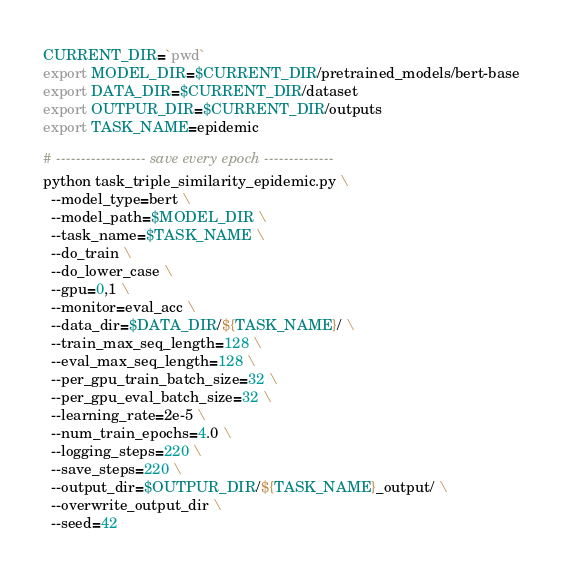<code> <loc_0><loc_0><loc_500><loc_500><_Bash_>CURRENT_DIR=`pwd`
export MODEL_DIR=$CURRENT_DIR/pretrained_models/bert-base
export DATA_DIR=$CURRENT_DIR/dataset
export OUTPUR_DIR=$CURRENT_DIR/outputs
export TASK_NAME=epidemic

# ------------------ save every epoch --------------
python task_triple_similarity_epidemic.py \
  --model_type=bert \
  --model_path=$MODEL_DIR \
  --task_name=$TASK_NAME \
  --do_train \
  --do_lower_case \
  --gpu=0,1 \
  --monitor=eval_acc \
  --data_dir=$DATA_DIR/${TASK_NAME}/ \
  --train_max_seq_length=128 \
  --eval_max_seq_length=128 \
  --per_gpu_train_batch_size=32 \
  --per_gpu_eval_batch_size=32 \
  --learning_rate=2e-5 \
  --num_train_epochs=4.0 \
  --logging_steps=220 \
  --save_steps=220 \
  --output_dir=$OUTPUR_DIR/${TASK_NAME}_output/ \
  --overwrite_output_dir \
  --seed=42
</code> 